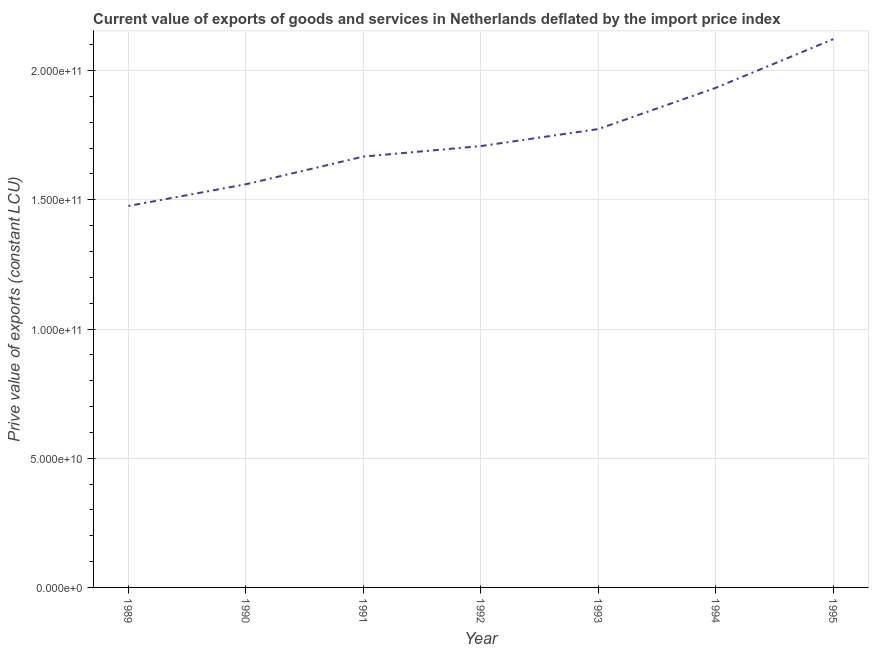What is the price value of exports in 1993?
Keep it short and to the point. 1.77e+11. Across all years, what is the maximum price value of exports?
Ensure brevity in your answer.  2.12e+11. Across all years, what is the minimum price value of exports?
Give a very brief answer. 1.48e+11. In which year was the price value of exports minimum?
Offer a very short reply. 1989. What is the sum of the price value of exports?
Give a very brief answer. 1.22e+12. What is the difference between the price value of exports in 1992 and 1993?
Offer a terse response. -6.59e+09. What is the average price value of exports per year?
Make the answer very short. 1.75e+11. What is the median price value of exports?
Ensure brevity in your answer.  1.71e+11. In how many years, is the price value of exports greater than 150000000000 LCU?
Your answer should be compact. 6. What is the ratio of the price value of exports in 1990 to that in 1994?
Provide a succinct answer. 0.81. What is the difference between the highest and the second highest price value of exports?
Provide a short and direct response. 1.88e+1. Is the sum of the price value of exports in 1993 and 1994 greater than the maximum price value of exports across all years?
Give a very brief answer. Yes. What is the difference between the highest and the lowest price value of exports?
Offer a terse response. 6.46e+1. What is the difference between two consecutive major ticks on the Y-axis?
Make the answer very short. 5.00e+1. Are the values on the major ticks of Y-axis written in scientific E-notation?
Provide a short and direct response. Yes. Does the graph contain any zero values?
Give a very brief answer. No. Does the graph contain grids?
Give a very brief answer. Yes. What is the title of the graph?
Your answer should be very brief. Current value of exports of goods and services in Netherlands deflated by the import price index. What is the label or title of the X-axis?
Make the answer very short. Year. What is the label or title of the Y-axis?
Make the answer very short. Prive value of exports (constant LCU). What is the Prive value of exports (constant LCU) in 1989?
Ensure brevity in your answer.  1.48e+11. What is the Prive value of exports (constant LCU) of 1990?
Offer a very short reply. 1.56e+11. What is the Prive value of exports (constant LCU) in 1991?
Offer a very short reply. 1.67e+11. What is the Prive value of exports (constant LCU) of 1992?
Your response must be concise. 1.71e+11. What is the Prive value of exports (constant LCU) of 1993?
Provide a succinct answer. 1.77e+11. What is the Prive value of exports (constant LCU) of 1994?
Give a very brief answer. 1.93e+11. What is the Prive value of exports (constant LCU) of 1995?
Provide a short and direct response. 2.12e+11. What is the difference between the Prive value of exports (constant LCU) in 1989 and 1990?
Make the answer very short. -8.39e+09. What is the difference between the Prive value of exports (constant LCU) in 1989 and 1991?
Offer a very short reply. -1.91e+1. What is the difference between the Prive value of exports (constant LCU) in 1989 and 1992?
Offer a terse response. -2.32e+1. What is the difference between the Prive value of exports (constant LCU) in 1989 and 1993?
Offer a terse response. -2.98e+1. What is the difference between the Prive value of exports (constant LCU) in 1989 and 1994?
Ensure brevity in your answer.  -4.57e+1. What is the difference between the Prive value of exports (constant LCU) in 1989 and 1995?
Provide a short and direct response. -6.46e+1. What is the difference between the Prive value of exports (constant LCU) in 1990 and 1991?
Keep it short and to the point. -1.07e+1. What is the difference between the Prive value of exports (constant LCU) in 1990 and 1992?
Provide a short and direct response. -1.48e+1. What is the difference between the Prive value of exports (constant LCU) in 1990 and 1993?
Offer a very short reply. -2.14e+1. What is the difference between the Prive value of exports (constant LCU) in 1990 and 1994?
Ensure brevity in your answer.  -3.73e+1. What is the difference between the Prive value of exports (constant LCU) in 1990 and 1995?
Ensure brevity in your answer.  -5.62e+1. What is the difference between the Prive value of exports (constant LCU) in 1991 and 1992?
Provide a short and direct response. -4.06e+09. What is the difference between the Prive value of exports (constant LCU) in 1991 and 1993?
Your response must be concise. -1.07e+1. What is the difference between the Prive value of exports (constant LCU) in 1991 and 1994?
Ensure brevity in your answer.  -2.66e+1. What is the difference between the Prive value of exports (constant LCU) in 1991 and 1995?
Ensure brevity in your answer.  -4.54e+1. What is the difference between the Prive value of exports (constant LCU) in 1992 and 1993?
Your answer should be compact. -6.59e+09. What is the difference between the Prive value of exports (constant LCU) in 1992 and 1994?
Offer a terse response. -2.25e+1. What is the difference between the Prive value of exports (constant LCU) in 1992 and 1995?
Provide a succinct answer. -4.14e+1. What is the difference between the Prive value of exports (constant LCU) in 1993 and 1994?
Your answer should be compact. -1.60e+1. What is the difference between the Prive value of exports (constant LCU) in 1993 and 1995?
Ensure brevity in your answer.  -3.48e+1. What is the difference between the Prive value of exports (constant LCU) in 1994 and 1995?
Offer a very short reply. -1.88e+1. What is the ratio of the Prive value of exports (constant LCU) in 1989 to that in 1990?
Give a very brief answer. 0.95. What is the ratio of the Prive value of exports (constant LCU) in 1989 to that in 1991?
Provide a succinct answer. 0.89. What is the ratio of the Prive value of exports (constant LCU) in 1989 to that in 1992?
Offer a terse response. 0.86. What is the ratio of the Prive value of exports (constant LCU) in 1989 to that in 1993?
Provide a succinct answer. 0.83. What is the ratio of the Prive value of exports (constant LCU) in 1989 to that in 1994?
Offer a terse response. 0.76. What is the ratio of the Prive value of exports (constant LCU) in 1989 to that in 1995?
Ensure brevity in your answer.  0.7. What is the ratio of the Prive value of exports (constant LCU) in 1990 to that in 1991?
Your answer should be compact. 0.94. What is the ratio of the Prive value of exports (constant LCU) in 1990 to that in 1992?
Your answer should be compact. 0.91. What is the ratio of the Prive value of exports (constant LCU) in 1990 to that in 1993?
Make the answer very short. 0.88. What is the ratio of the Prive value of exports (constant LCU) in 1990 to that in 1994?
Offer a terse response. 0.81. What is the ratio of the Prive value of exports (constant LCU) in 1990 to that in 1995?
Keep it short and to the point. 0.73. What is the ratio of the Prive value of exports (constant LCU) in 1991 to that in 1992?
Make the answer very short. 0.98. What is the ratio of the Prive value of exports (constant LCU) in 1991 to that in 1993?
Your response must be concise. 0.94. What is the ratio of the Prive value of exports (constant LCU) in 1991 to that in 1994?
Offer a terse response. 0.86. What is the ratio of the Prive value of exports (constant LCU) in 1991 to that in 1995?
Provide a short and direct response. 0.79. What is the ratio of the Prive value of exports (constant LCU) in 1992 to that in 1993?
Ensure brevity in your answer.  0.96. What is the ratio of the Prive value of exports (constant LCU) in 1992 to that in 1994?
Offer a terse response. 0.88. What is the ratio of the Prive value of exports (constant LCU) in 1992 to that in 1995?
Your answer should be compact. 0.81. What is the ratio of the Prive value of exports (constant LCU) in 1993 to that in 1994?
Keep it short and to the point. 0.92. What is the ratio of the Prive value of exports (constant LCU) in 1993 to that in 1995?
Give a very brief answer. 0.84. What is the ratio of the Prive value of exports (constant LCU) in 1994 to that in 1995?
Keep it short and to the point. 0.91. 